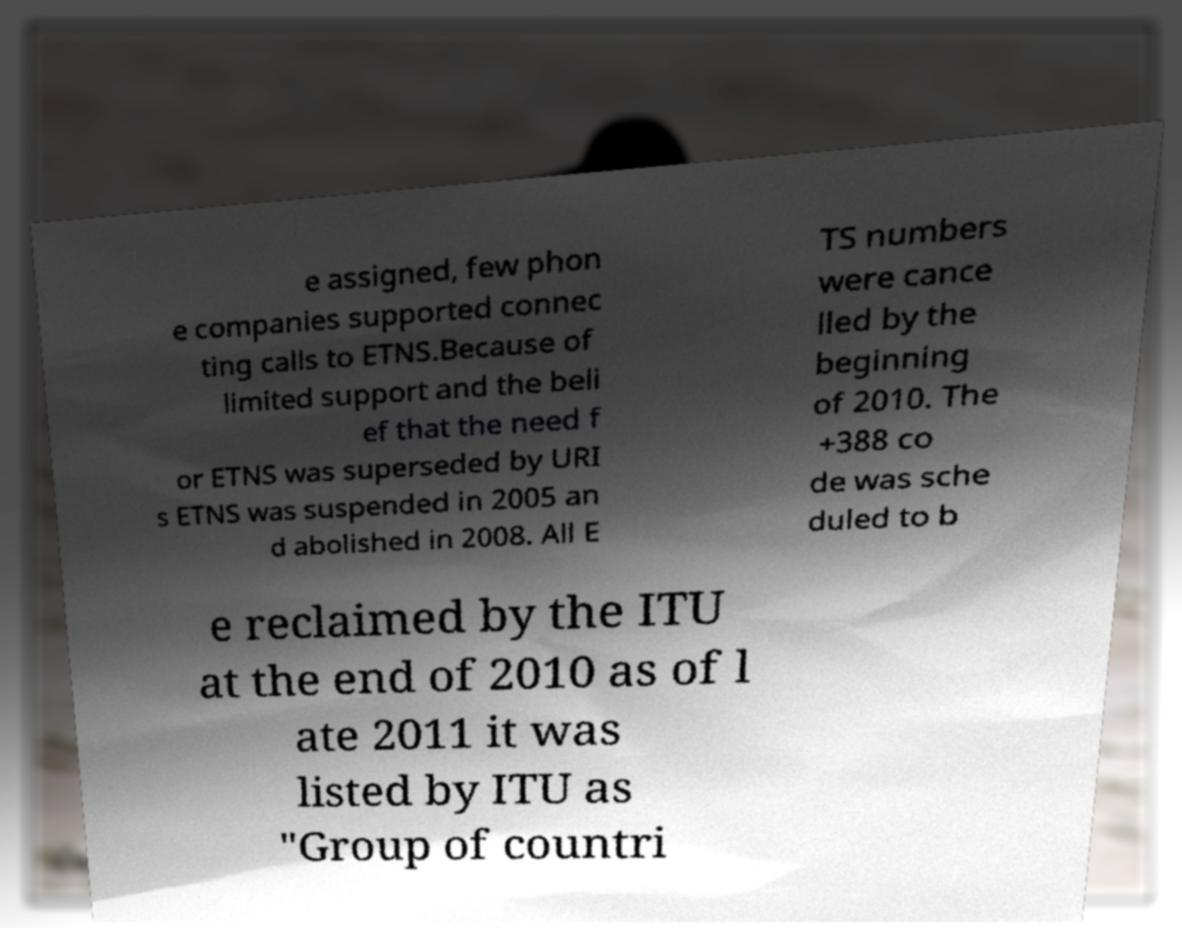There's text embedded in this image that I need extracted. Can you transcribe it verbatim? e assigned, few phon e companies supported connec ting calls to ETNS.Because of limited support and the beli ef that the need f or ETNS was superseded by URI s ETNS was suspended in 2005 an d abolished in 2008. All E TS numbers were cance lled by the beginning of 2010. The +388 co de was sche duled to b e reclaimed by the ITU at the end of 2010 as of l ate 2011 it was listed by ITU as "Group of countri 